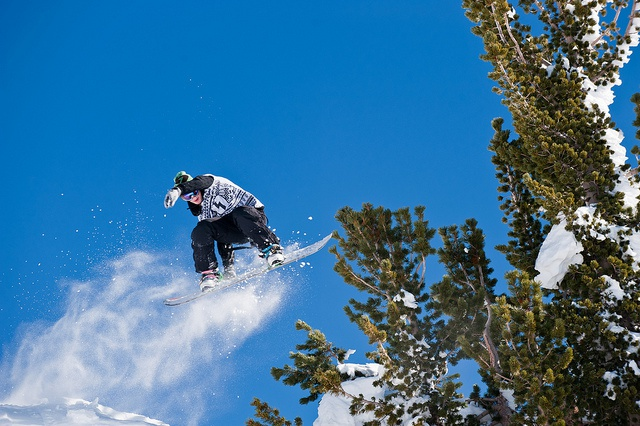Describe the objects in this image and their specific colors. I can see people in blue, black, lightgray, gray, and darkgray tones and snowboard in blue, darkgray, lightgray, and gray tones in this image. 